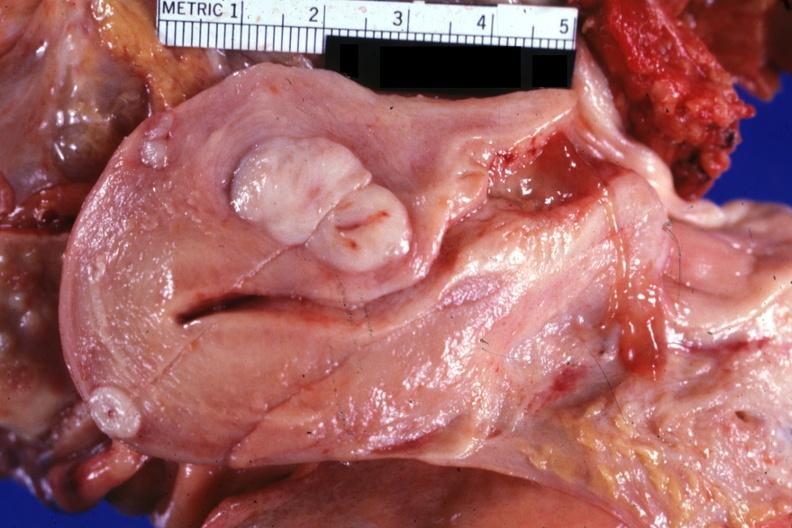s good example of muscle atrophy present?
Answer the question using a single word or phrase. No 